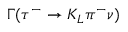Convert formula to latex. <formula><loc_0><loc_0><loc_500><loc_500>\Gamma ( \tau ^ { - } \to K _ { L } \pi ^ { - } { \nu } )</formula> 